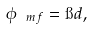<formula> <loc_0><loc_0><loc_500><loc_500>\phi _ { \ m f } = \i d ,</formula> 